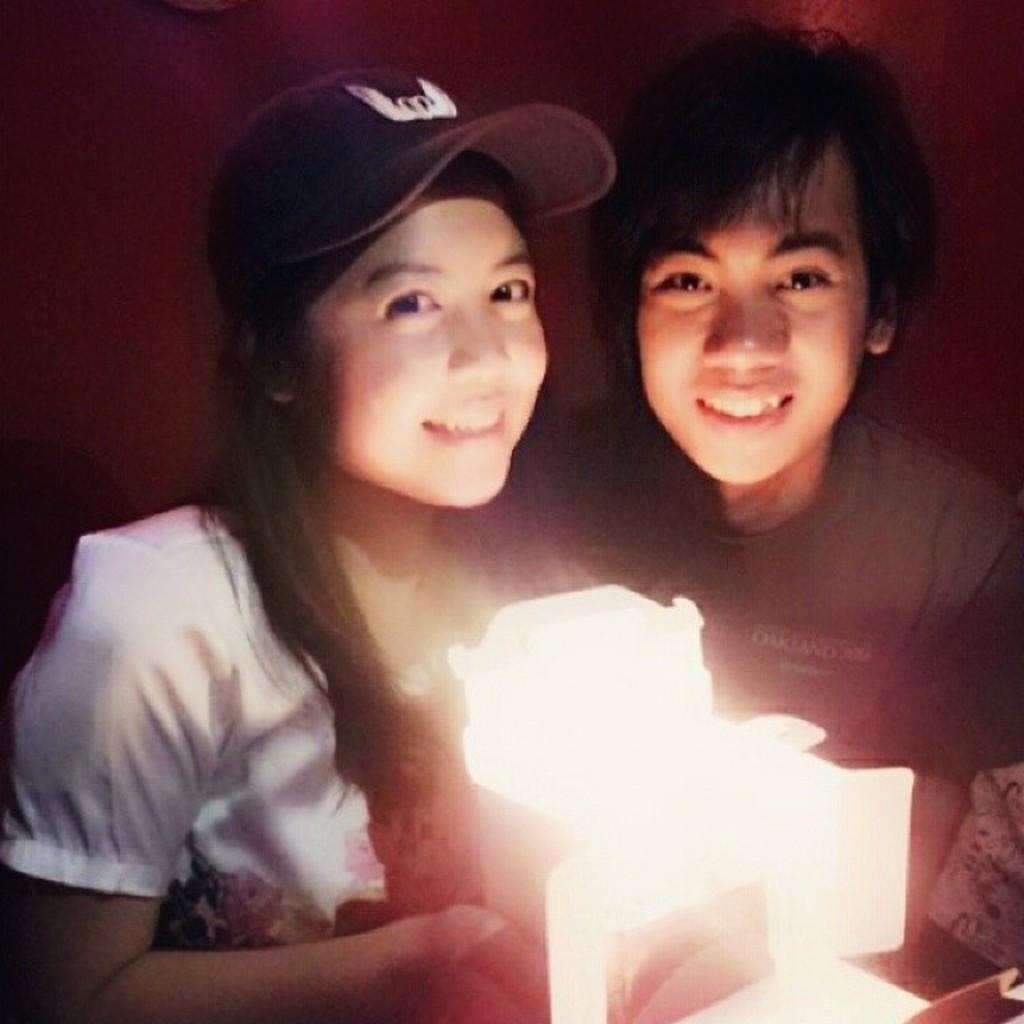Could you give a brief overview of what you see in this image? In the center of the picture there is a man and a woman, they are holding an object which is emitting light. Behind them it is well. 